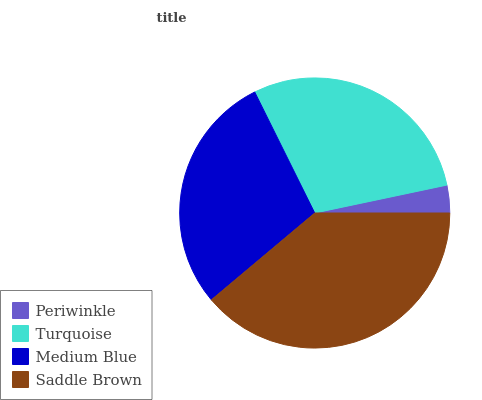Is Periwinkle the minimum?
Answer yes or no. Yes. Is Saddle Brown the maximum?
Answer yes or no. Yes. Is Turquoise the minimum?
Answer yes or no. No. Is Turquoise the maximum?
Answer yes or no. No. Is Turquoise greater than Periwinkle?
Answer yes or no. Yes. Is Periwinkle less than Turquoise?
Answer yes or no. Yes. Is Periwinkle greater than Turquoise?
Answer yes or no. No. Is Turquoise less than Periwinkle?
Answer yes or no. No. Is Turquoise the high median?
Answer yes or no. Yes. Is Medium Blue the low median?
Answer yes or no. Yes. Is Saddle Brown the high median?
Answer yes or no. No. Is Turquoise the low median?
Answer yes or no. No. 